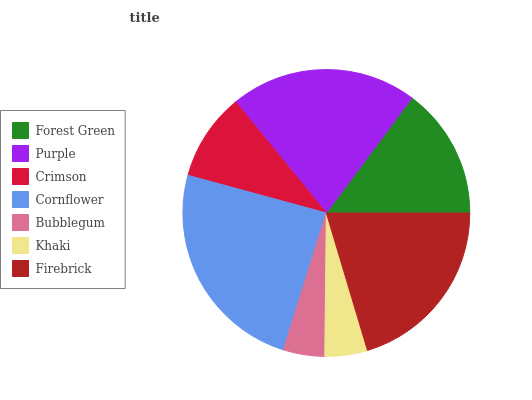Is Bubblegum the minimum?
Answer yes or no. Yes. Is Cornflower the maximum?
Answer yes or no. Yes. Is Purple the minimum?
Answer yes or no. No. Is Purple the maximum?
Answer yes or no. No. Is Purple greater than Forest Green?
Answer yes or no. Yes. Is Forest Green less than Purple?
Answer yes or no. Yes. Is Forest Green greater than Purple?
Answer yes or no. No. Is Purple less than Forest Green?
Answer yes or no. No. Is Forest Green the high median?
Answer yes or no. Yes. Is Forest Green the low median?
Answer yes or no. Yes. Is Firebrick the high median?
Answer yes or no. No. Is Khaki the low median?
Answer yes or no. No. 